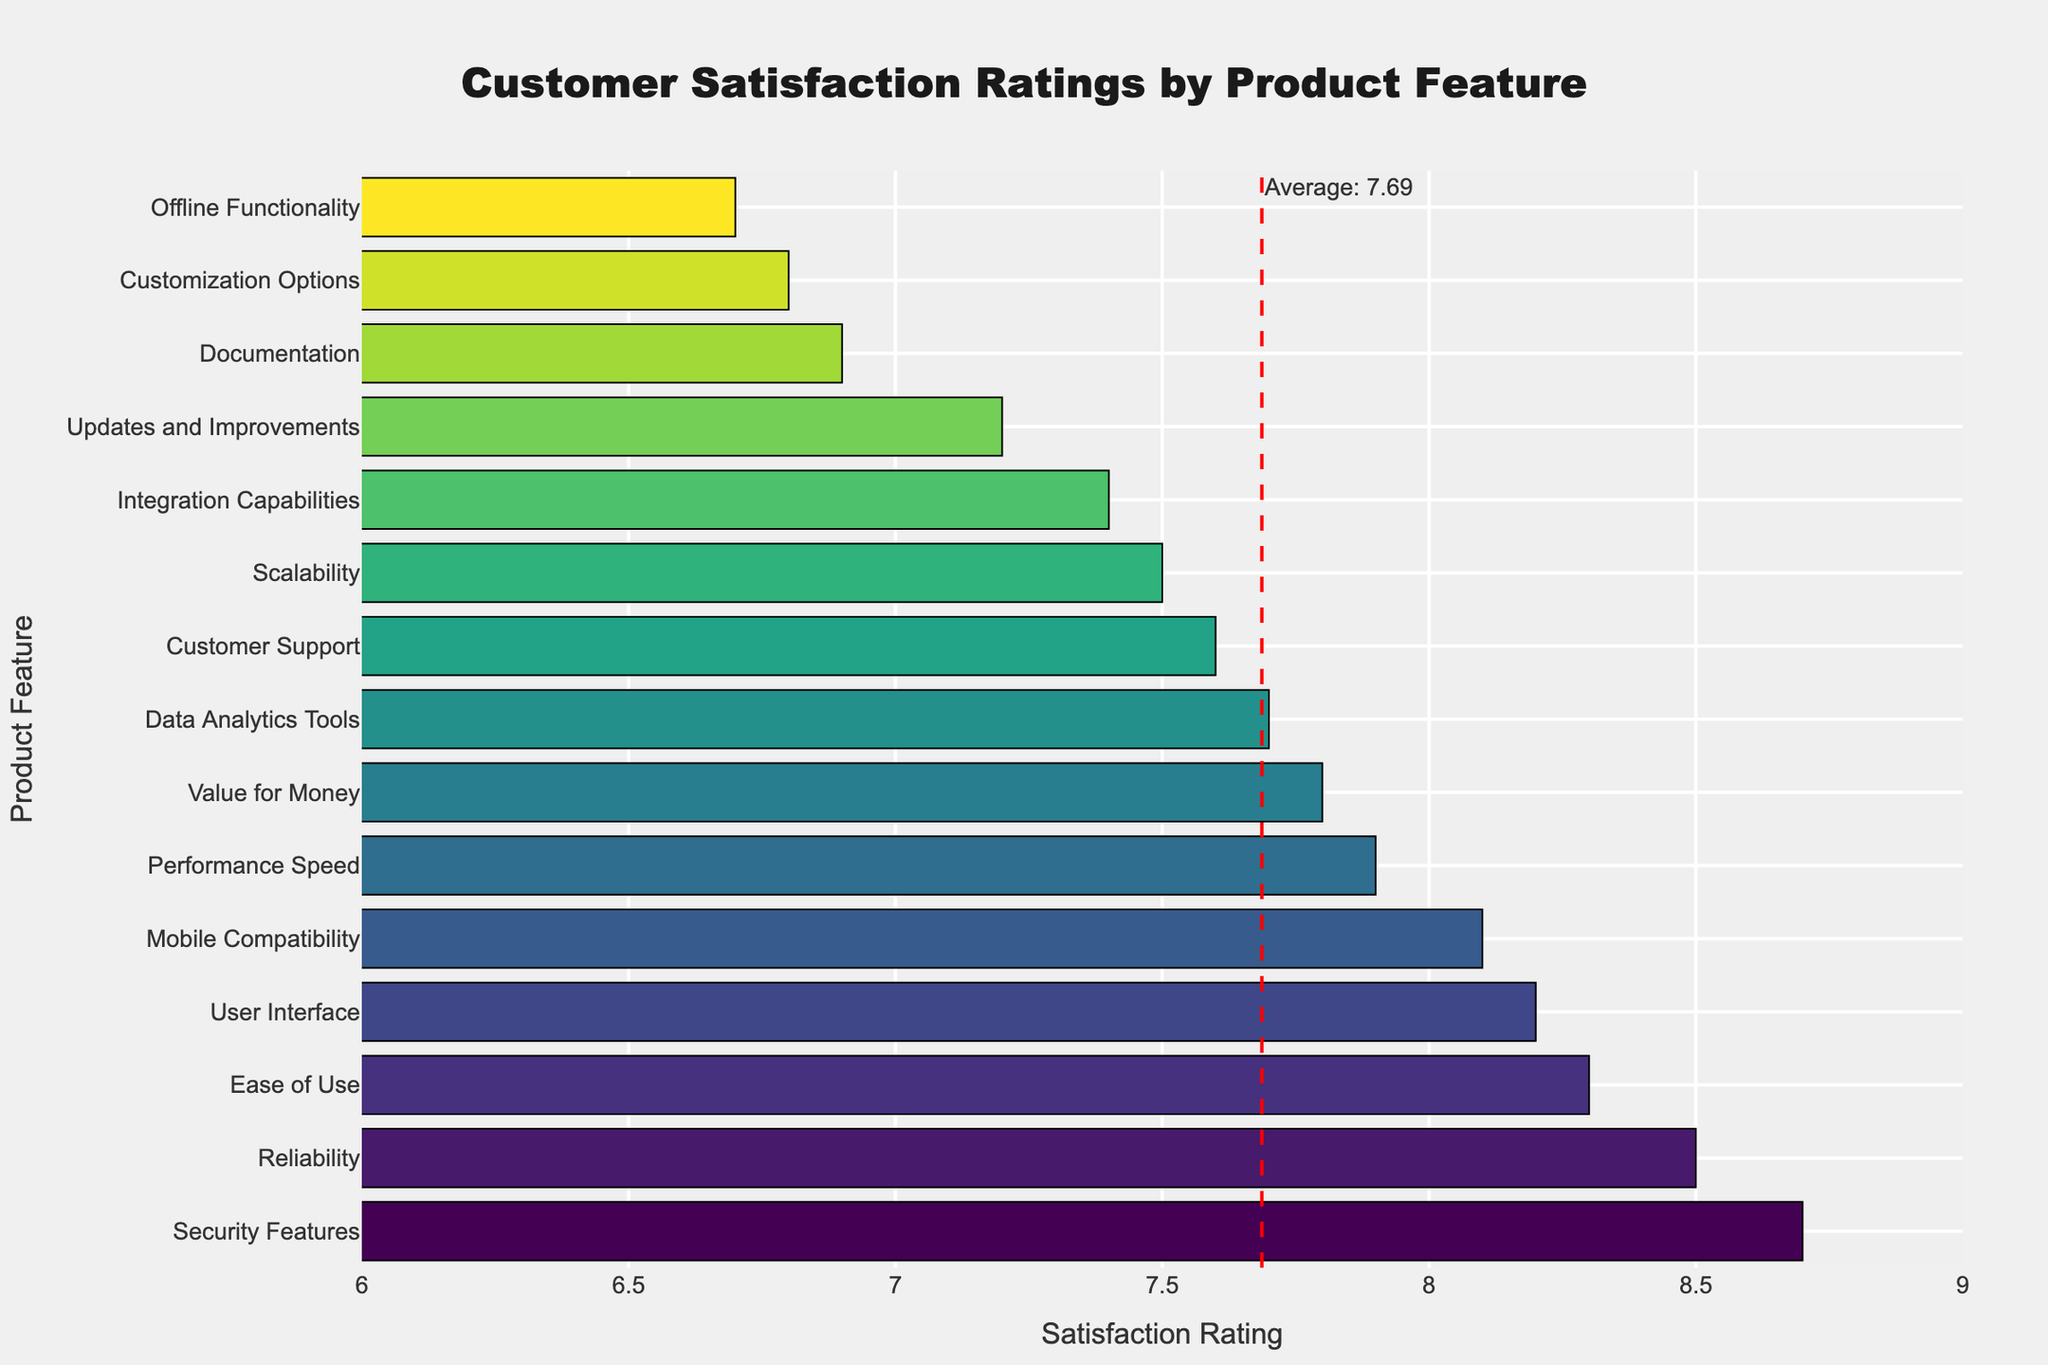What's the highest customer satisfaction rating? Look at the highest bar in the chart, which corresponds to the feature "Security Features". The satisfaction rating for "Security Features" is 8.7.
Answer: 8.7 Which feature has the lowest customer satisfaction rating? Identify the shortest bar in the chart; it corresponds to "Offline Functionality" with a satisfaction rating of 6.7.
Answer: Offline Functionality How does the satisfaction rating of "Customer Support" compare with "User Interface"? Locate the bars for "Customer Support" and "User Interface." "Customer Support" has a satisfaction rating of 7.6, while "User Interface" has a rating of 8.2. Compare these two values.
Answer: Customer Support is lower What is the average customer satisfaction rating across all features? The average satisfaction rating is marked by a red dashed line in the chart. The annotation next to the line states the average rating is 7.67.
Answer: 7.67 Which feature has a satisfaction rating closest to the average? The red dashed line indicates the average rating. Identify the bar closest to this line; "Value for Money" has a rating of 7.8, which is very close to the average.
Answer: Value for Money Which two features have the most similar customer satisfaction ratings? Look for bars that have very similar lengths. "Updates and Improvements" (7.2) and "Documentation" (6.9) are quite close, but "Scalability" (7.5) and "Integration Capabilities" (7.4) are even closer.
Answer: Scalability and Integration Capabilities What is the difference in satisfaction ratings between the highest and lowest rated features? Find the difference between the highest rating (8.7 for "Security Features") and the lowest rating (6.7 for "Offline Functionality"). This is calculated as 8.7 - 6.7 = 2.0.
Answer: 2.0 How many features have a satisfaction rating above 8? Count the number of bars that exceed the value of 8. These are "Security Features," "Ease of Use," "Reliability," "User Interface," and "Mobile Compatibility." There are 5 such features.
Answer: 5 Which feature improved the most if it was noted that "Customization Options" had a previous satisfaction rating of 4.5? "Customization Options" currently has a rating of 6.8. The improvement is 6.8 - 4.5 = 2.3. Check if this is more than any other mentioned improvements (if any).
Answer: Customization Options What is the median satisfaction rating of all features? List all ratings in ascending order: 6.7, 6.8, 6.9, 7.2, 7.4, 7.5, 7.6, 7.7, 7.8, 7.9, 8.1, 8.2, 8.3, 8.5, 8.7. The median, being the middle value, is 7.7 ("Data Analytics Tools").
Answer: 7.7 